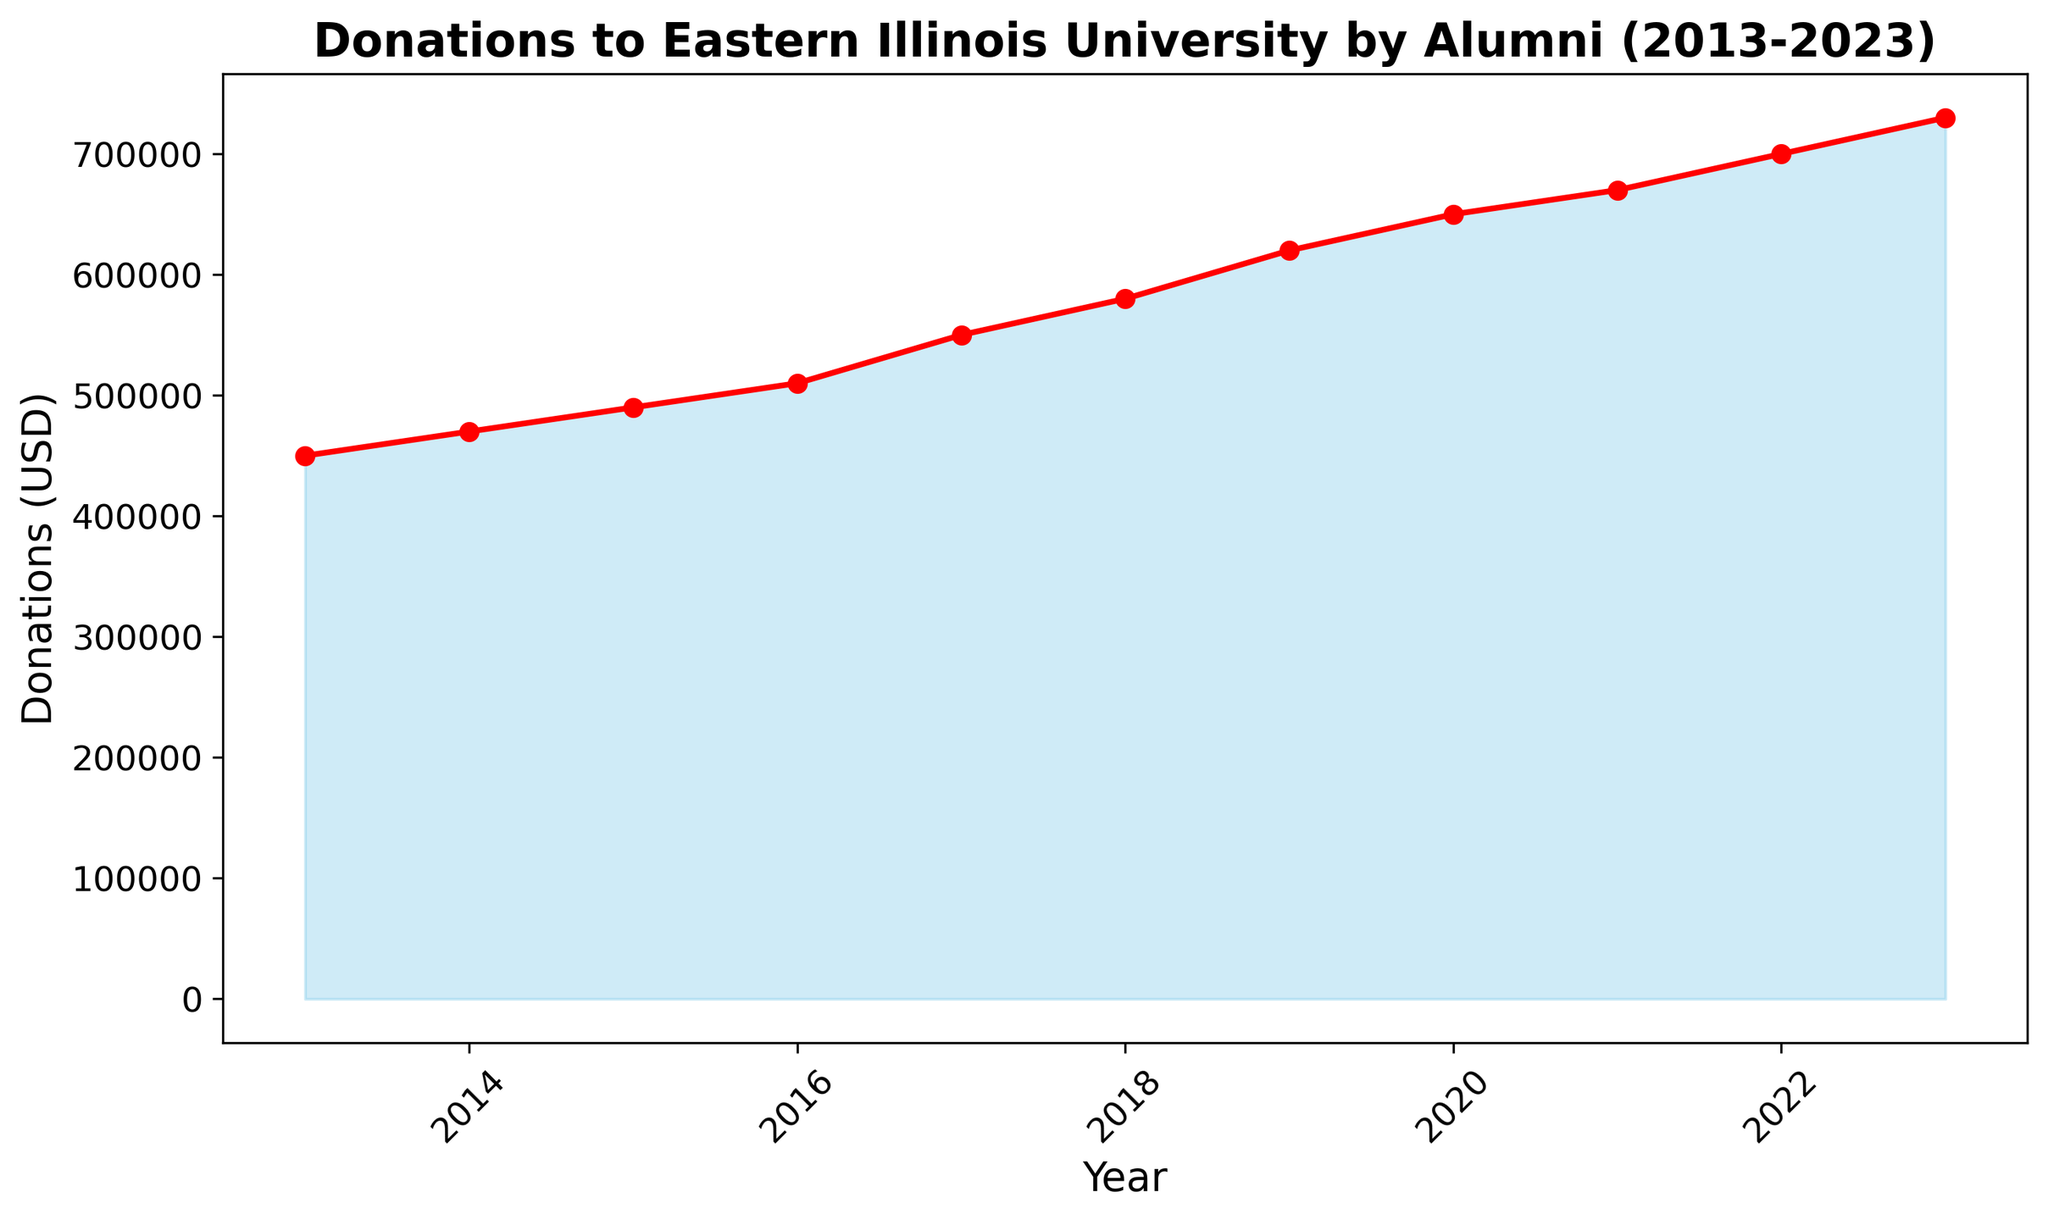What is the total donation amount from 2013 to 2023? To find the total donation amount from 2013 to 2023, sum the donations for each year: 450,000 + 470,000 + 490,000 + 510,000 + 550,000 + 580,000 + 620,000 + 650,000 + 670,000 + 700,000 + 730,000 = 6,420,000.
Answer: 6,420,000 Which year had the highest donation amount, and what was the amount? The year with the highest donation amount is the one with the highest point on the plot. From the data, the year 2023 had the highest donation amount at 730,000.
Answer: 2023, 730,000 Between which consecutive years did the donation amount increase the most, and by how much? To determine the largest increase, calculate the differences between each consecutive year: (2023-2022) 730,000 - 700,000 = 30,000; (2022-2021) 700,000 - 670,000 = 30,000; (2021-2020) 670,000 - 650,000 = 20,000; (2020-2019) 650,000 - 620,000 = 30,000; (2019-2018) 620,000 - 580,000 = 40,000; (2018-2017) 580,000 - 550,000 = 30,000; (2017-2016) 550,000 - 510,000 = 40,000; (2016-2015) 510,000 - 490,000 = 20,000; (2015-2014) 490,000 - 470,000 = 20,000; (2014-2013) 470,000 - 450,000 = 20,000. The largest increase is 40,000 between 2017 and 2018, and 2019 and 2020.
Answer: 2017 to 2018, 40,000 What is the average donation amount over the 11-year period? To find the average donation amount, sum all donations and divide by the number of years: (450,000 + 470,000 + 490,000 + 510,000 + 550,000 + 580,000 + 620,000 + 650,000 + 670,000 + 700,000 + 730,000) / 11 = 6,420,000 / 11 = 583,636.36.
Answer: 583,636.36 What is the difference in donation amounts between the years 2016 and 2020? To find the difference, subtract the donation amount of 2016 from 2020: 650,000 - 510,000 = 140,000.
Answer: 140,000 How many years experienced an increase in donations compared to the previous year? By comparing each year to the previous year, we see that every year shows an increase in donation amounts. Therefore, all 10 years (from 2014 to 2023) experienced an increase.
Answer: 10 Which years had donation amounts greater than 600,000? The donation amounts greater than 600,000 are recorded in 2019 (620,000), 2020 (650,000), 2021 (670,000), 2022 (700,000), and 2023 (730,000).
Answer: 2019, 2020, 2021, 2022, 2023 In terms of visual height, which year shows the most prominent change in the area chart? Visual prominence on an area chart corresponds to noticeable height difference. Based on the data and the plotted area chart, the years 2017 and 2018 as well as 2019 show the most prominent change due to the highest incremental amounts of 40,000.
Answer: 2017-2018, 2018-2019 By what percentage did the donations increase from 2013 to 2023? To calculate the percentage increase from 2013 to 2023: first, find the difference (730,000 - 450,000 = 280,000), then divide by the 2013 amount (280,000 / 450,000 = 0.6222) and multiply by 100 to convert to percentage (62.22%).
Answer: 62.22% 